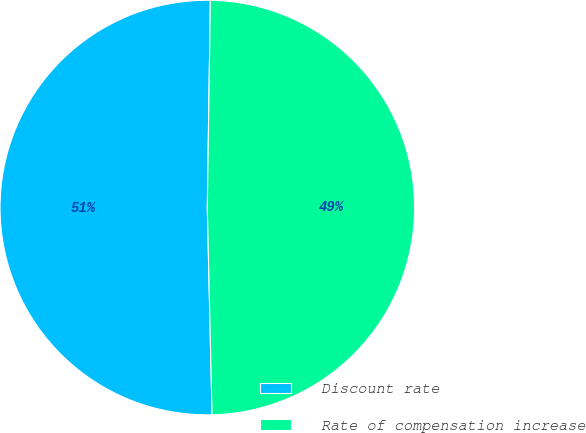Convert chart. <chart><loc_0><loc_0><loc_500><loc_500><pie_chart><fcel>Discount rate<fcel>Rate of compensation increase<nl><fcel>50.6%<fcel>49.4%<nl></chart> 